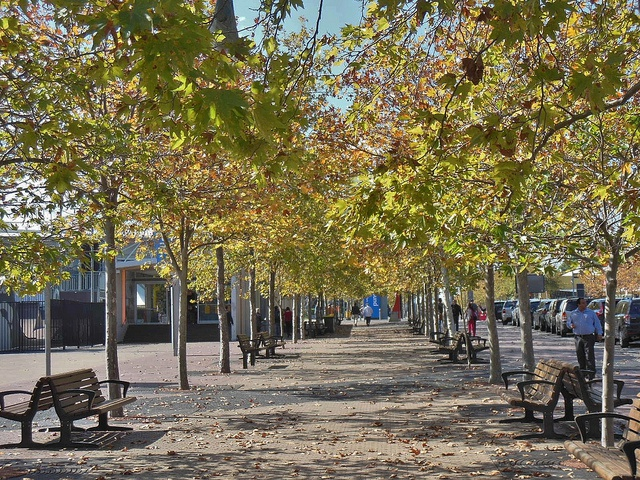Describe the objects in this image and their specific colors. I can see bench in gray, black, tan, and darkgray tones, bench in gray and black tones, bench in gray, black, and darkgray tones, car in gray, black, and darkgray tones, and bench in gray, black, and darkgray tones in this image. 